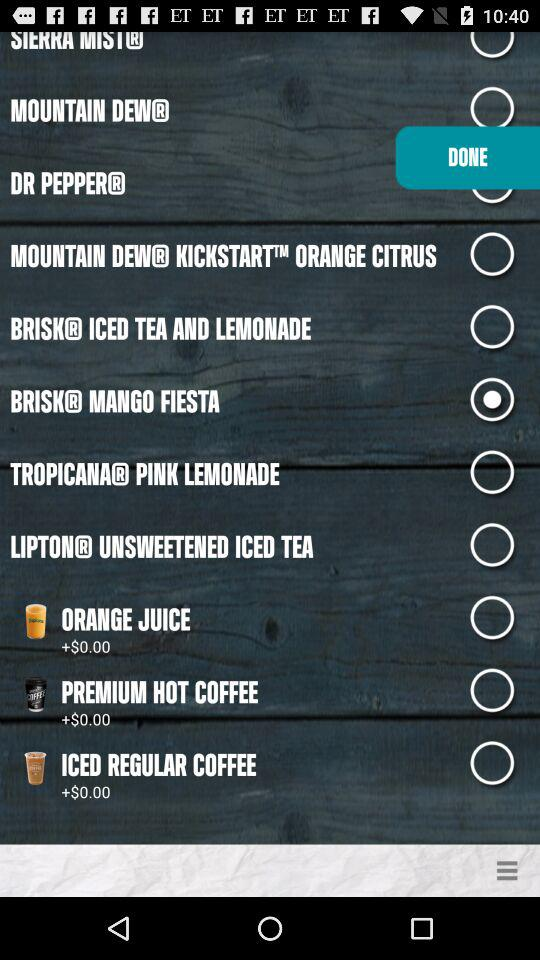How much does a "PREMIUM HOT COFFEE" cost? The cost is $0.00. 